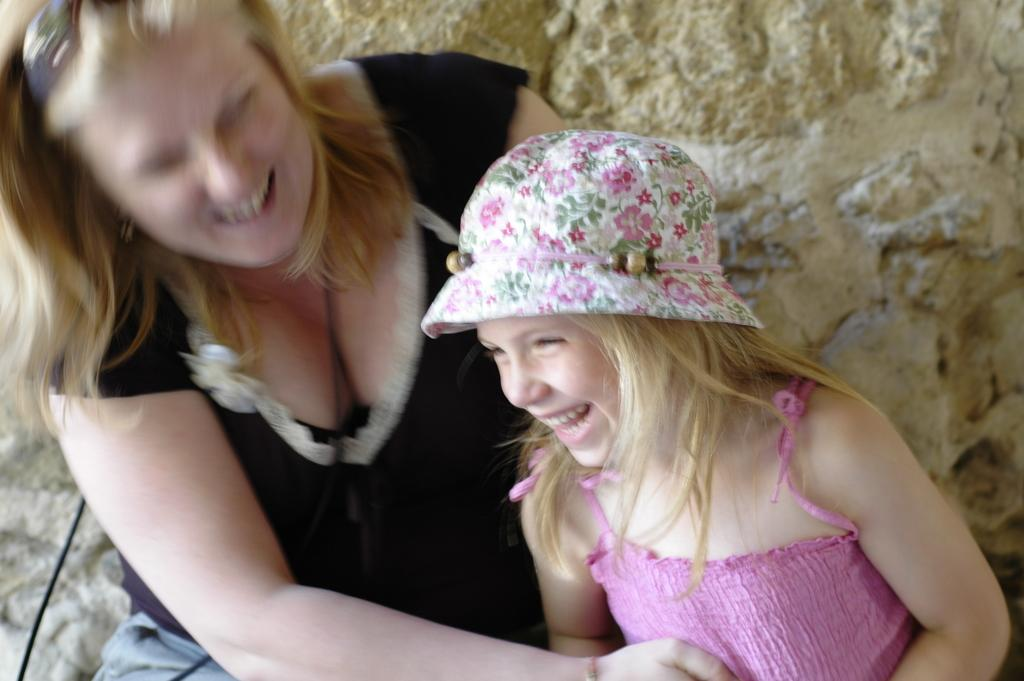Who is present in the image? There is a woman and a girl in the image. What are the expressions on their faces? Both the woman and the girl are smiling. What is the girl wearing on her head? The girl is wearing a cap. What can be seen in the background of the image? There is a cream-colored wall in the background of the image. What type of mitten can be seen on the woman's hand in the image? There are no mittens present in the image; the woman and the girl are not wearing any gloves or mittens. 